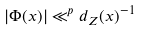Convert formula to latex. <formula><loc_0><loc_0><loc_500><loc_500>| \Phi ( x ) | \ll ^ { p } d _ { Z } ( x ) ^ { - 1 }</formula> 